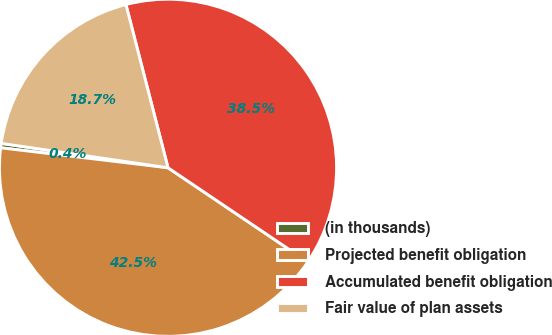Convert chart to OTSL. <chart><loc_0><loc_0><loc_500><loc_500><pie_chart><fcel>(in thousands)<fcel>Projected benefit obligation<fcel>Accumulated benefit obligation<fcel>Fair value of plan assets<nl><fcel>0.42%<fcel>42.45%<fcel>38.45%<fcel>18.67%<nl></chart> 